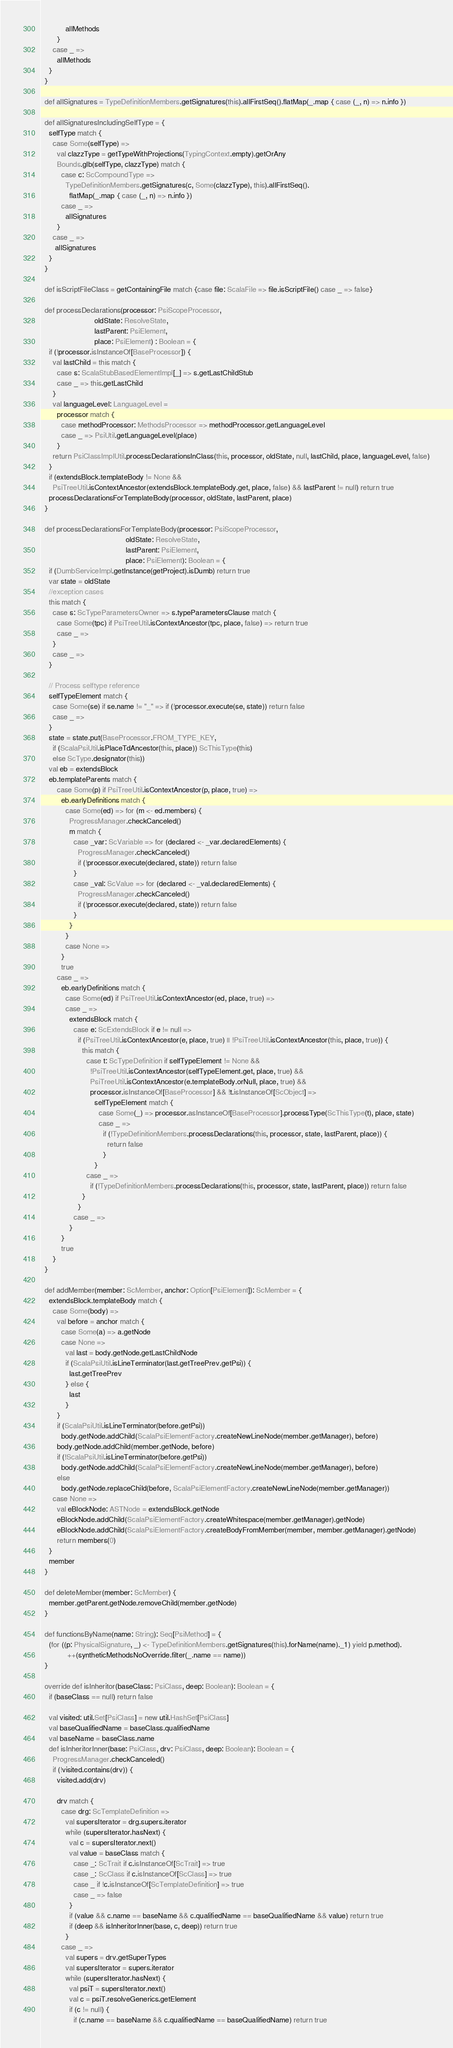<code> <loc_0><loc_0><loc_500><loc_500><_Scala_>            allMethods
        }
      case _ =>
        allMethods
    }
  }

  def allSignatures = TypeDefinitionMembers.getSignatures(this).allFirstSeq().flatMap(_.map { case (_, n) => n.info })

  def allSignaturesIncludingSelfType = {
    selfType match {
      case Some(selfType) =>
        val clazzType = getTypeWithProjections(TypingContext.empty).getOrAny
        Bounds.glb(selfType, clazzType) match {
          case c: ScCompoundType =>
            TypeDefinitionMembers.getSignatures(c, Some(clazzType), this).allFirstSeq().
              flatMap(_.map { case (_, n) => n.info })
          case _ =>
            allSignatures
        }
      case _ =>
       allSignatures
    }
  }

  def isScriptFileClass = getContainingFile match {case file: ScalaFile => file.isScriptFile() case _ => false}

  def processDeclarations(processor: PsiScopeProcessor,
                          oldState: ResolveState,
                          lastParent: PsiElement,
                          place: PsiElement) : Boolean = {
    if (!processor.isInstanceOf[BaseProcessor]) {
      val lastChild = this match {
        case s: ScalaStubBasedElementImpl[_] => s.getLastChildStub
        case _ => this.getLastChild
      }
      val languageLevel: LanguageLevel =
        processor match {
          case methodProcessor: MethodsProcessor => methodProcessor.getLanguageLevel
          case _ => PsiUtil.getLanguageLevel(place)
        }
      return PsiClassImplUtil.processDeclarationsInClass(this, processor, oldState, null, lastChild, place, languageLevel, false)
    }
    if (extendsBlock.templateBody != None &&
      PsiTreeUtil.isContextAncestor(extendsBlock.templateBody.get, place, false) && lastParent != null) return true
    processDeclarationsForTemplateBody(processor, oldState, lastParent, place)
  }

  def processDeclarationsForTemplateBody(processor: PsiScopeProcessor,
                                         oldState: ResolveState,
                                         lastParent: PsiElement,
                                         place: PsiElement): Boolean = {
    if (DumbServiceImpl.getInstance(getProject).isDumb) return true
    var state = oldState
    //exception cases
    this match {
      case s: ScTypeParametersOwner => s.typeParametersClause match {
        case Some(tpc) if PsiTreeUtil.isContextAncestor(tpc, place, false) => return true
        case _ =>
      }
      case _ =>
    }

    // Process selftype reference
    selfTypeElement match {
      case Some(se) if se.name != "_" => if (!processor.execute(se, state)) return false
      case _ =>
    }
    state = state.put(BaseProcessor.FROM_TYPE_KEY,
      if (ScalaPsiUtil.isPlaceTdAncestor(this, place)) ScThisType(this)
      else ScType.designator(this))
    val eb = extendsBlock
    eb.templateParents match {
        case Some(p) if PsiTreeUtil.isContextAncestor(p, place, true) =>
          eb.earlyDefinitions match {
            case Some(ed) => for (m <- ed.members) {
              ProgressManager.checkCanceled()
              m match {
                case _var: ScVariable => for (declared <- _var.declaredElements) {
                  ProgressManager.checkCanceled()
                  if (!processor.execute(declared, state)) return false
                }
                case _val: ScValue => for (declared <- _val.declaredElements) {
                  ProgressManager.checkCanceled()
                  if (!processor.execute(declared, state)) return false
                }
              }
            }
            case None =>
          }
          true
        case _ =>
          eb.earlyDefinitions match {
            case Some(ed) if PsiTreeUtil.isContextAncestor(ed, place, true) =>
            case _ =>
              extendsBlock match {
                case e: ScExtendsBlock if e != null =>
                  if (PsiTreeUtil.isContextAncestor(e, place, true) || !PsiTreeUtil.isContextAncestor(this, place, true)) {
                    this match {
                      case t: ScTypeDefinition if selfTypeElement != None &&
                        !PsiTreeUtil.isContextAncestor(selfTypeElement.get, place, true) &&
                        PsiTreeUtil.isContextAncestor(e.templateBody.orNull, place, true) &&
                        processor.isInstanceOf[BaseProcessor] && !t.isInstanceOf[ScObject] =>
                          selfTypeElement match {
                            case Some(_) => processor.asInstanceOf[BaseProcessor].processType(ScThisType(t), place, state)
                            case _ =>
                              if (!TypeDefinitionMembers.processDeclarations(this, processor, state, lastParent, place)) {
                                return false
                              }
                          }
                      case _ =>
                        if (!TypeDefinitionMembers.processDeclarations(this, processor, state, lastParent, place)) return false
                    }
                  }
                case _ =>
              }
          }
          true
      }
  }

  def addMember(member: ScMember, anchor: Option[PsiElement]): ScMember = {
    extendsBlock.templateBody match {
      case Some(body) =>
        val before = anchor match {
          case Some(a) => a.getNode
          case None =>
            val last = body.getNode.getLastChildNode
            if (ScalaPsiUtil.isLineTerminator(last.getTreePrev.getPsi)) {
              last.getTreePrev
            } else {
              last
            }
        }
        if (ScalaPsiUtil.isLineTerminator(before.getPsi))
          body.getNode.addChild(ScalaPsiElementFactory.createNewLineNode(member.getManager), before)
        body.getNode.addChild(member.getNode, before)
        if (!ScalaPsiUtil.isLineTerminator(before.getPsi))
          body.getNode.addChild(ScalaPsiElementFactory.createNewLineNode(member.getManager), before)
        else
          body.getNode.replaceChild(before, ScalaPsiElementFactory.createNewLineNode(member.getManager))
      case None =>
        val eBlockNode: ASTNode = extendsBlock.getNode
        eBlockNode.addChild(ScalaPsiElementFactory.createWhitespace(member.getManager).getNode)
        eBlockNode.addChild(ScalaPsiElementFactory.createBodyFromMember(member, member.getManager).getNode)
        return members(0)
    }
    member
  }

  def deleteMember(member: ScMember) {
    member.getParent.getNode.removeChild(member.getNode)
  }

  def functionsByName(name: String): Seq[PsiMethod] = {
    (for ((p: PhysicalSignature, _) <- TypeDefinitionMembers.getSignatures(this).forName(name)._1) yield p.method).
             ++(syntheticMethodsNoOverride.filter(_.name == name))
  }

  override def isInheritor(baseClass: PsiClass, deep: Boolean): Boolean = {
    if (baseClass == null) return false

    val visited: util.Set[PsiClass] = new util.HashSet[PsiClass]
    val baseQualifiedName = baseClass.qualifiedName
    val baseName = baseClass.name
    def isInheritorInner(base: PsiClass, drv: PsiClass, deep: Boolean): Boolean = {
      ProgressManager.checkCanceled()
      if (!visited.contains(drv)) {
        visited.add(drv)

        drv match {
          case drg: ScTemplateDefinition =>
            val supersIterator = drg.supers.iterator
            while (supersIterator.hasNext) {
              val c = supersIterator.next()
              val value = baseClass match {
                case _: ScTrait if c.isInstanceOf[ScTrait] => true
                case _: ScClass if c.isInstanceOf[ScClass] => true
                case _ if !c.isInstanceOf[ScTemplateDefinition] => true
                case _ => false
              }
              if (value && c.name == baseName && c.qualifiedName == baseQualifiedName && value) return true
              if (deep && isInheritorInner(base, c, deep)) return true
            }
          case _ =>
            val supers = drv.getSuperTypes
            val supersIterator = supers.iterator
            while (supersIterator.hasNext) {
              val psiT = supersIterator.next()
              val c = psiT.resolveGenerics.getElement
              if (c != null) {
                if (c.name == baseName && c.qualifiedName == baseQualifiedName) return true</code> 